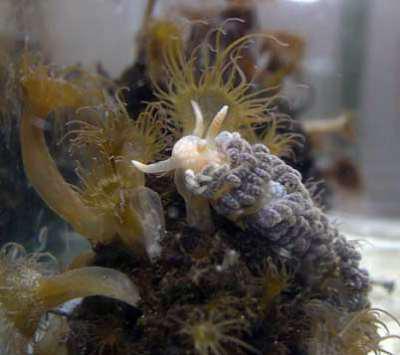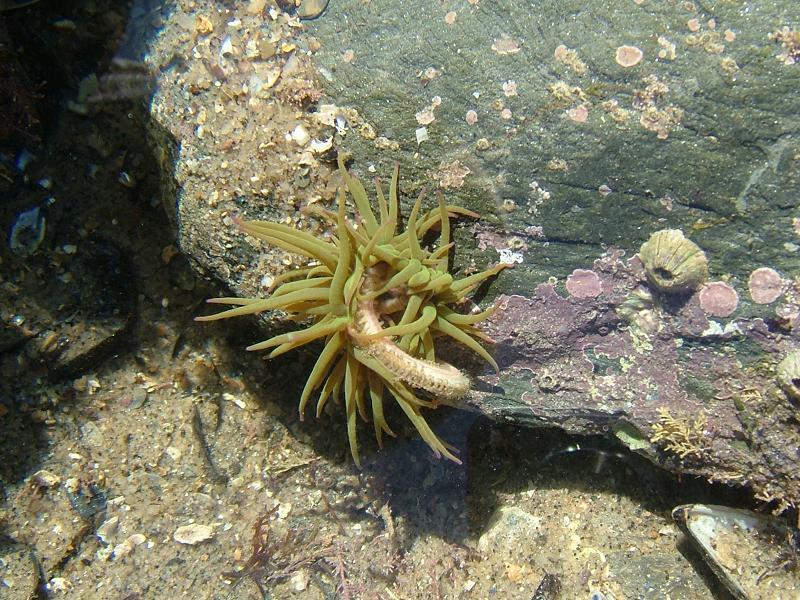The first image is the image on the left, the second image is the image on the right. Considering the images on both sides, is "At least one image shows an anemone-type creature with tendrils in ombre green, blue and purple shades." valid? Answer yes or no. No. The first image is the image on the left, the second image is the image on the right. For the images shown, is this caption "In the right image, the sea slug has blue-ish arms/tentacles." true? Answer yes or no. No. 